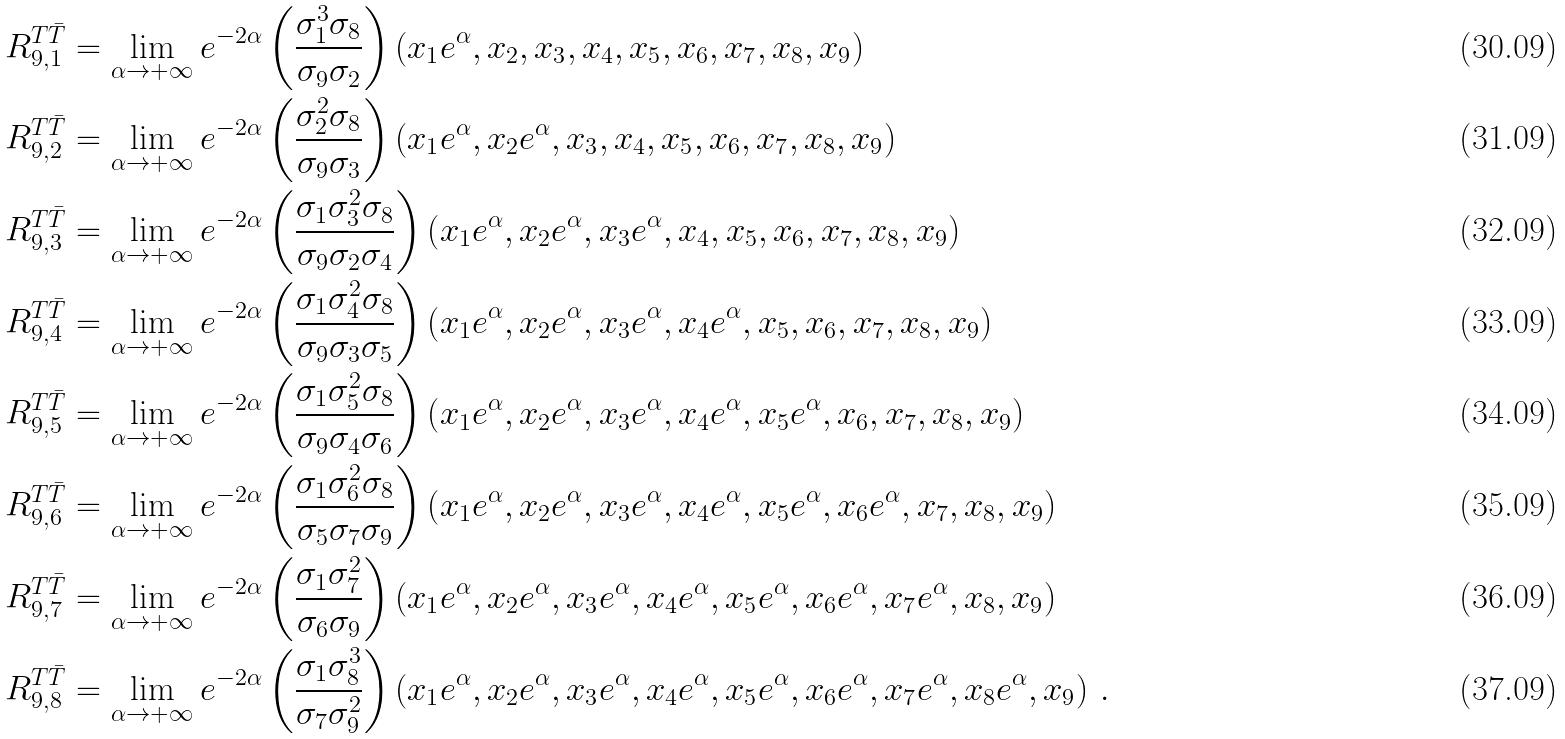<formula> <loc_0><loc_0><loc_500><loc_500>R _ { 9 , 1 } ^ { T \bar { T } } & = \lim _ { \alpha \rightarrow + \infty } e ^ { - 2 \alpha } \left ( \frac { \sigma _ { 1 } ^ { 3 } \sigma _ { 8 } } { \sigma _ { 9 } \sigma _ { 2 } } \right ) \left ( x _ { 1 } e ^ { \alpha } , x _ { 2 } , x _ { 3 } , x _ { 4 } , x _ { 5 } , x _ { 6 } , x _ { 7 } , x _ { 8 } , x _ { 9 } \right ) \\ R _ { 9 , 2 } ^ { T \bar { T } } & = \lim _ { \alpha \rightarrow + \infty } e ^ { - 2 \alpha } \left ( \frac { \sigma _ { 2 } ^ { 2 } \sigma _ { 8 } } { \sigma _ { 9 } \sigma _ { 3 } } \right ) \left ( x _ { 1 } e ^ { \alpha } , x _ { 2 } e ^ { \alpha } , x _ { 3 } , x _ { 4 } , x _ { 5 } , x _ { 6 } , x _ { 7 } , x _ { 8 } , x _ { 9 } \right ) \\ R _ { 9 , 3 } ^ { T \bar { T } } & = \lim _ { \alpha \rightarrow + \infty } e ^ { - 2 \alpha } \left ( \frac { \sigma _ { 1 } \sigma _ { 3 } ^ { 2 } \sigma _ { 8 } } { \sigma _ { 9 } \sigma _ { 2 } \sigma _ { 4 } } \right ) \left ( x _ { 1 } e ^ { \alpha } , x _ { 2 } e ^ { \alpha } , x _ { 3 } e ^ { \alpha } , x _ { 4 } , x _ { 5 } , x _ { 6 } , x _ { 7 } , x _ { 8 } , x _ { 9 } \right ) \\ R _ { 9 , 4 } ^ { T \bar { T } } & = \lim _ { \alpha \rightarrow + \infty } e ^ { - 2 \alpha } \left ( \frac { \sigma _ { 1 } \sigma _ { 4 } ^ { 2 } \sigma _ { 8 } } { \sigma _ { 9 } \sigma _ { 3 } \sigma _ { 5 } } \right ) \left ( x _ { 1 } e ^ { \alpha } , x _ { 2 } e ^ { \alpha } , x _ { 3 } e ^ { \alpha } , x _ { 4 } e ^ { \alpha } , x _ { 5 } , x _ { 6 } , x _ { 7 } , x _ { 8 } , x _ { 9 } \right ) \\ R _ { 9 , 5 } ^ { T \bar { T } } & = \lim _ { \alpha \rightarrow + \infty } e ^ { - 2 \alpha } \left ( \frac { \sigma _ { 1 } \sigma _ { 5 } ^ { 2 } \sigma _ { 8 } } { \sigma _ { 9 } \sigma _ { 4 } \sigma _ { 6 } } \right ) \left ( x _ { 1 } e ^ { \alpha } , x _ { 2 } e ^ { \alpha } , x _ { 3 } e ^ { \alpha } , x _ { 4 } e ^ { \alpha } , x _ { 5 } e ^ { \alpha } , x _ { 6 } , x _ { 7 } , x _ { 8 } , x _ { 9 } \right ) \\ R _ { 9 , 6 } ^ { T \bar { T } } & = \lim _ { \alpha \rightarrow + \infty } e ^ { - 2 \alpha } \left ( \frac { \sigma _ { 1 } \sigma _ { 6 } ^ { 2 } \sigma _ { 8 } } { \sigma _ { 5 } \sigma _ { 7 } \sigma _ { 9 } } \right ) \left ( x _ { 1 } e ^ { \alpha } , x _ { 2 } e ^ { \alpha } , x _ { 3 } e ^ { \alpha } , x _ { 4 } e ^ { \alpha } , x _ { 5 } e ^ { \alpha } , x _ { 6 } e ^ { \alpha } , x _ { 7 } , x _ { 8 } , x _ { 9 } \right ) \\ R _ { 9 , 7 } ^ { T \bar { T } } & = \lim _ { \alpha \rightarrow + \infty } e ^ { - 2 \alpha } \left ( \frac { \sigma _ { 1 } \sigma _ { 7 } ^ { 2 } } { \sigma _ { 6 } \sigma _ { 9 } } \right ) \left ( x _ { 1 } e ^ { \alpha } , x _ { 2 } e ^ { \alpha } , x _ { 3 } e ^ { \alpha } , x _ { 4 } e ^ { \alpha } , x _ { 5 } e ^ { \alpha } , x _ { 6 } e ^ { \alpha } , x _ { 7 } e ^ { \alpha } , x _ { 8 } , x _ { 9 } \right ) \\ R _ { 9 , 8 } ^ { T \bar { T } } & = \lim _ { \alpha \rightarrow + \infty } e ^ { - 2 \alpha } \left ( \frac { \sigma _ { 1 } \sigma _ { 8 } ^ { 3 } } { \sigma _ { 7 } \sigma _ { 9 } ^ { 2 } } \right ) \left ( x _ { 1 } e ^ { \alpha } , x _ { 2 } e ^ { \alpha } , x _ { 3 } e ^ { \alpha } , x _ { 4 } e ^ { \alpha } , x _ { 5 } e ^ { \alpha } , x _ { 6 } e ^ { \alpha } , x _ { 7 } e ^ { \alpha } , x _ { 8 } e ^ { \alpha } , x _ { 9 } \right ) \, .</formula> 